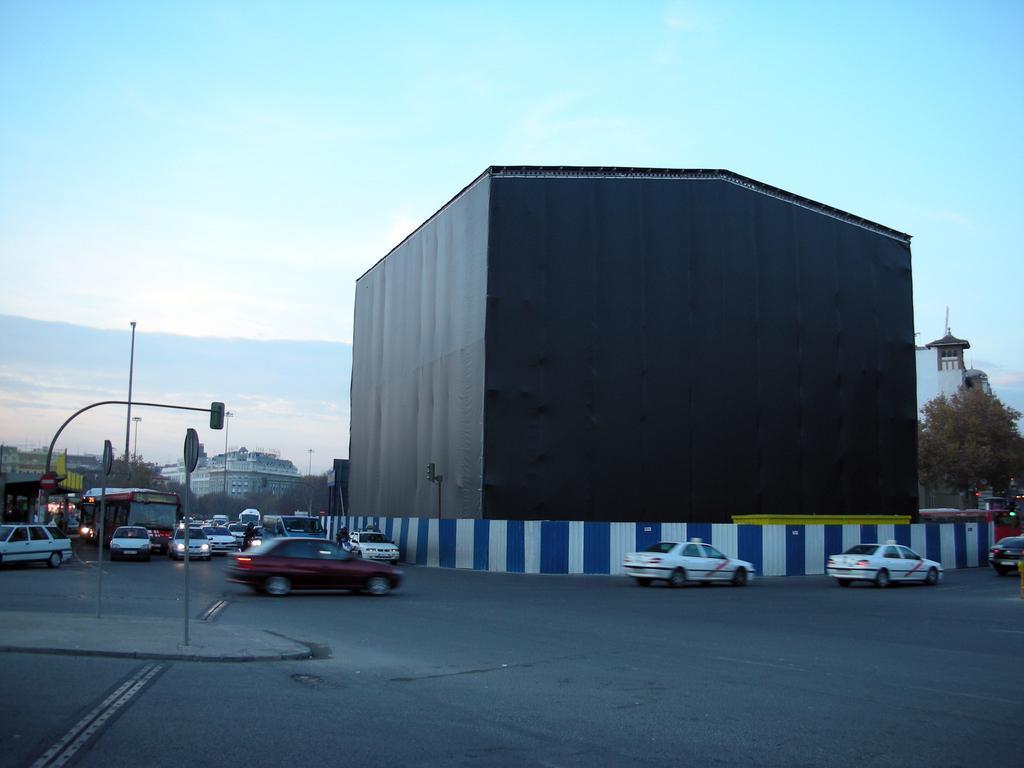Could you give a brief overview of what you see in this image? In this picture there is an object which is in black color and there is fence around it and there are few vehicles on the road and there are buildings in the background and there are few poles in the left corner. 